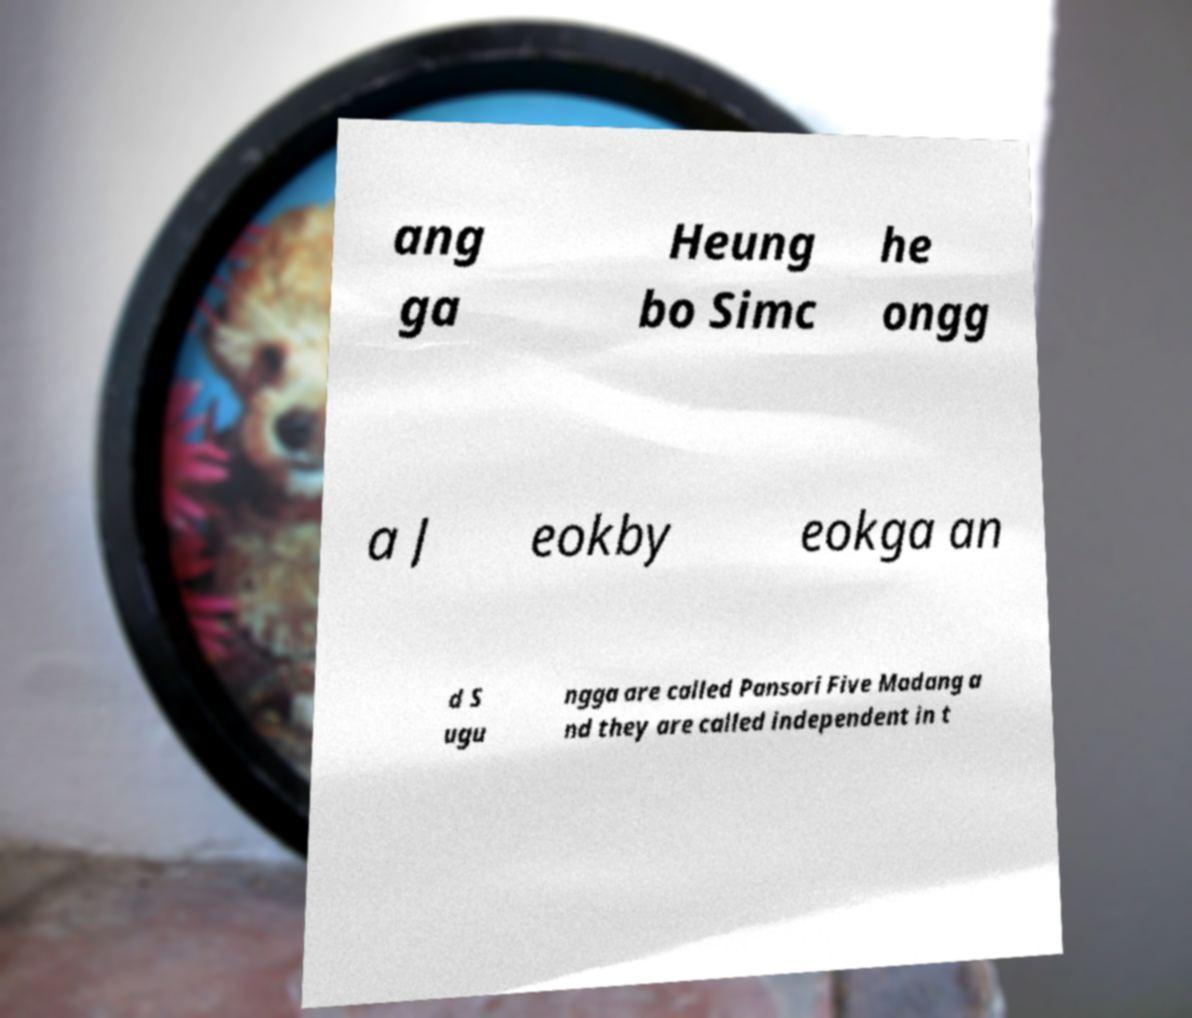For documentation purposes, I need the text within this image transcribed. Could you provide that? ang ga Heung bo Simc he ongg a J eokby eokga an d S ugu ngga are called Pansori Five Madang a nd they are called independent in t 